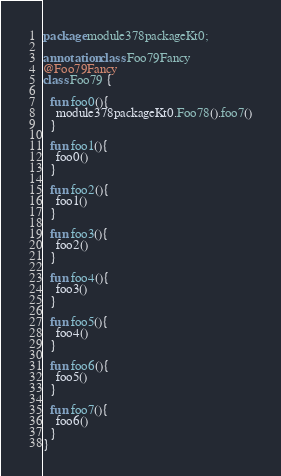<code> <loc_0><loc_0><loc_500><loc_500><_Kotlin_>package module378packageKt0;

annotation class Foo79Fancy
@Foo79Fancy
class Foo79 {

  fun foo0(){
    module378packageKt0.Foo78().foo7()
  }

  fun foo1(){
    foo0()
  }

  fun foo2(){
    foo1()
  }

  fun foo3(){
    foo2()
  }

  fun foo4(){
    foo3()
  }

  fun foo5(){
    foo4()
  }

  fun foo6(){
    foo5()
  }

  fun foo7(){
    foo6()
  }
}</code> 